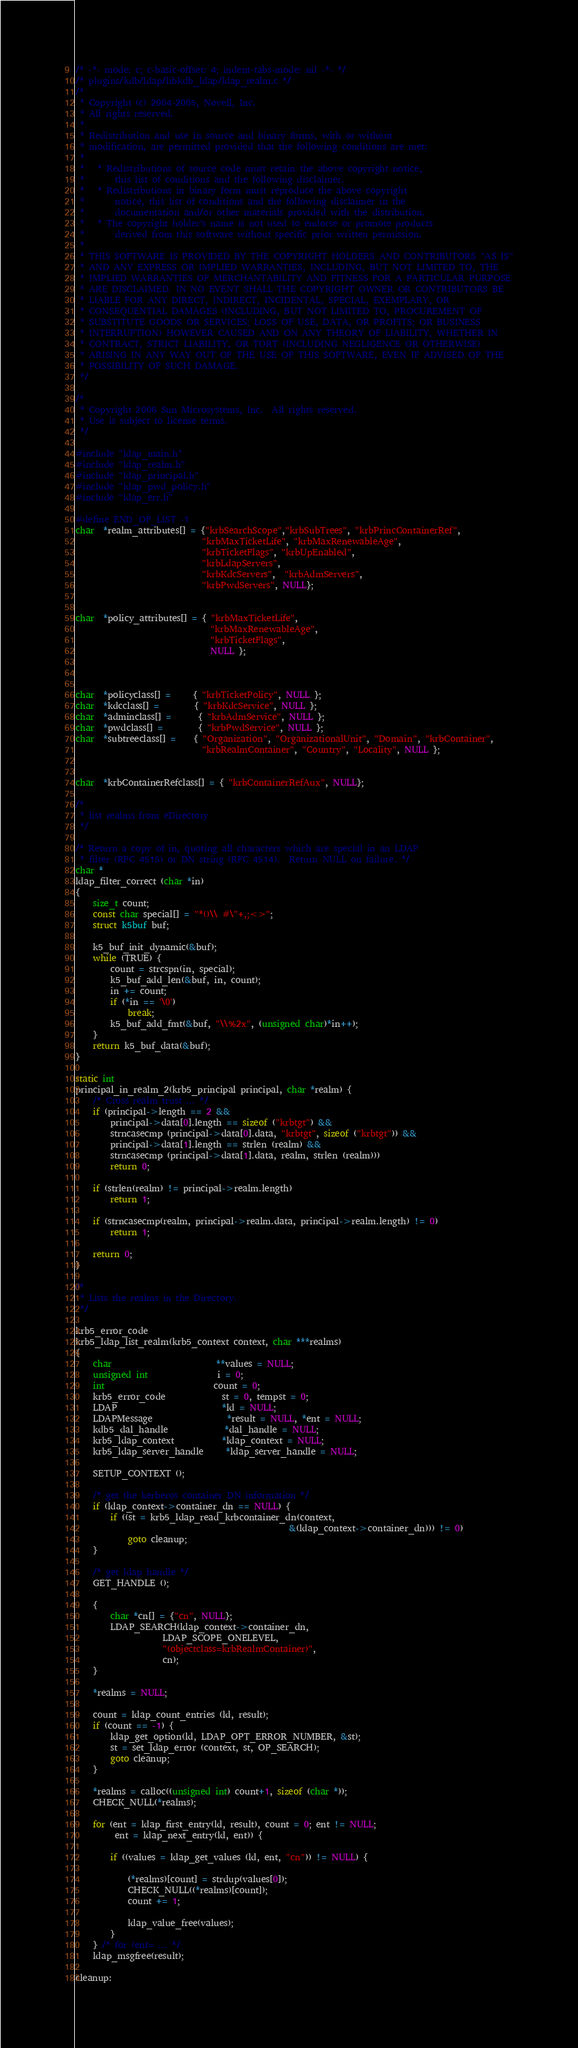<code> <loc_0><loc_0><loc_500><loc_500><_C_>/* -*- mode: c; c-basic-offset: 4; indent-tabs-mode: nil -*- */
/* plugins/kdb/ldap/libkdb_ldap/ldap_realm.c */
/*
 * Copyright (c) 2004-2005, Novell, Inc.
 * All rights reserved.
 *
 * Redistribution and use in source and binary forms, with or without
 * modification, are permitted provided that the following conditions are met:
 *
 *   * Redistributions of source code must retain the above copyright notice,
 *       this list of conditions and the following disclaimer.
 *   * Redistributions in binary form must reproduce the above copyright
 *       notice, this list of conditions and the following disclaimer in the
 *       documentation and/or other materials provided with the distribution.
 *   * The copyright holder's name is not used to endorse or promote products
 *       derived from this software without specific prior written permission.
 *
 * THIS SOFTWARE IS PROVIDED BY THE COPYRIGHT HOLDERS AND CONTRIBUTORS "AS IS"
 * AND ANY EXPRESS OR IMPLIED WARRANTIES, INCLUDING, BUT NOT LIMITED TO, THE
 * IMPLIED WARRANTIES OF MERCHANTABILITY AND FITNESS FOR A PARTICULAR PURPOSE
 * ARE DISCLAIMED. IN NO EVENT SHALL THE COPYRIGHT OWNER OR CONTRIBUTORS BE
 * LIABLE FOR ANY DIRECT, INDIRECT, INCIDENTAL, SPECIAL, EXEMPLARY, OR
 * CONSEQUENTIAL DAMAGES (INCLUDING, BUT NOT LIMITED TO, PROCUREMENT OF
 * SUBSTITUTE GOODS OR SERVICES; LOSS OF USE, DATA, OR PROFITS; OR BUSINESS
 * INTERRUPTION) HOWEVER CAUSED AND ON ANY THEORY OF LIABILITY, WHETHER IN
 * CONTRACT, STRICT LIABILITY, OR TORT (INCLUDING NEGLIGENCE OR OTHERWISE)
 * ARISING IN ANY WAY OUT OF THE USE OF THIS SOFTWARE, EVEN IF ADVISED OF THE
 * POSSIBILITY OF SUCH DAMAGE.
 */

/*
 * Copyright 2006 Sun Microsystems, Inc.  All rights reserved.
 * Use is subject to license terms.
 */

#include "ldap_main.h"
#include "ldap_realm.h"
#include "ldap_principal.h"
#include "ldap_pwd_policy.h"
#include "ldap_err.h"

#define END_OF_LIST -1
char  *realm_attributes[] = {"krbSearchScope","krbSubTrees", "krbPrincContainerRef",
                             "krbMaxTicketLife", "krbMaxRenewableAge",
                             "krbTicketFlags", "krbUpEnabled",
                             "krbLdapServers",
                             "krbKdcServers",  "krbAdmServers",
                             "krbPwdServers", NULL};


char  *policy_attributes[] = { "krbMaxTicketLife",
                               "krbMaxRenewableAge",
                               "krbTicketFlags",
                               NULL };



char  *policyclass[] =     { "krbTicketPolicy", NULL };
char  *kdcclass[] =        { "krbKdcService", NULL };
char  *adminclass[] =      { "krbAdmService", NULL };
char  *pwdclass[] =        { "krbPwdService", NULL };
char  *subtreeclass[] =    { "Organization", "OrganizationalUnit", "Domain", "krbContainer",
                             "krbRealmContainer", "Country", "Locality", NULL };


char  *krbContainerRefclass[] = { "krbContainerRefAux", NULL};

/*
 * list realms from eDirectory
 */

/* Return a copy of in, quoting all characters which are special in an LDAP
 * filter (RFC 4515) or DN string (RFC 4514).  Return NULL on failure. */
char *
ldap_filter_correct (char *in)
{
    size_t count;
    const char special[] = "*()\\ #\"+,;<>";
    struct k5buf buf;

    k5_buf_init_dynamic(&buf);
    while (TRUE) {
        count = strcspn(in, special);
        k5_buf_add_len(&buf, in, count);
        in += count;
        if (*in == '\0')
            break;
        k5_buf_add_fmt(&buf, "\\%2x", (unsigned char)*in++);
    }
    return k5_buf_data(&buf);
}

static int
principal_in_realm_2(krb5_principal principal, char *realm) {
    /* Cross realm trust ... */
    if (principal->length == 2 &&
        principal->data[0].length == sizeof ("krbtgt") &&
        strncasecmp (principal->data[0].data, "krbtgt", sizeof ("krbtgt")) &&
        principal->data[1].length == strlen (realm) &&
        strncasecmp (principal->data[1].data, realm, strlen (realm)))
        return 0;

    if (strlen(realm) != principal->realm.length)
        return 1;

    if (strncasecmp(realm, principal->realm.data, principal->realm.length) != 0)
        return 1;

    return 0;
}

/*
 * Lists the realms in the Directory.
 */

krb5_error_code
krb5_ldap_list_realm(krb5_context context, char ***realms)
{
    char                        **values = NULL;
    unsigned int                i = 0;
    int                         count = 0;
    krb5_error_code             st = 0, tempst = 0;
    LDAP                        *ld = NULL;
    LDAPMessage                 *result = NULL, *ent = NULL;
    kdb5_dal_handle             *dal_handle = NULL;
    krb5_ldap_context           *ldap_context = NULL;
    krb5_ldap_server_handle     *ldap_server_handle = NULL;

    SETUP_CONTEXT ();

    /* get the kerberos container DN information */
    if (ldap_context->container_dn == NULL) {
        if ((st = krb5_ldap_read_krbcontainer_dn(context,
                                                 &(ldap_context->container_dn))) != 0)
            goto cleanup;
    }

    /* get ldap handle */
    GET_HANDLE ();

    {
        char *cn[] = {"cn", NULL};
        LDAP_SEARCH(ldap_context->container_dn,
                    LDAP_SCOPE_ONELEVEL,
                    "(objectclass=krbRealmContainer)",
                    cn);
    }

    *realms = NULL;

    count = ldap_count_entries (ld, result);
    if (count == -1) {
        ldap_get_option(ld, LDAP_OPT_ERROR_NUMBER, &st);
        st = set_ldap_error (context, st, OP_SEARCH);
        goto cleanup;
    }

    *realms = calloc((unsigned int) count+1, sizeof (char *));
    CHECK_NULL(*realms);

    for (ent = ldap_first_entry(ld, result), count = 0; ent != NULL;
         ent = ldap_next_entry(ld, ent)) {

        if ((values = ldap_get_values (ld, ent, "cn")) != NULL) {

            (*realms)[count] = strdup(values[0]);
            CHECK_NULL((*realms)[count]);
            count += 1;

            ldap_value_free(values);
        }
    } /* for (ent= ... */
    ldap_msgfree(result);

cleanup:
</code> 